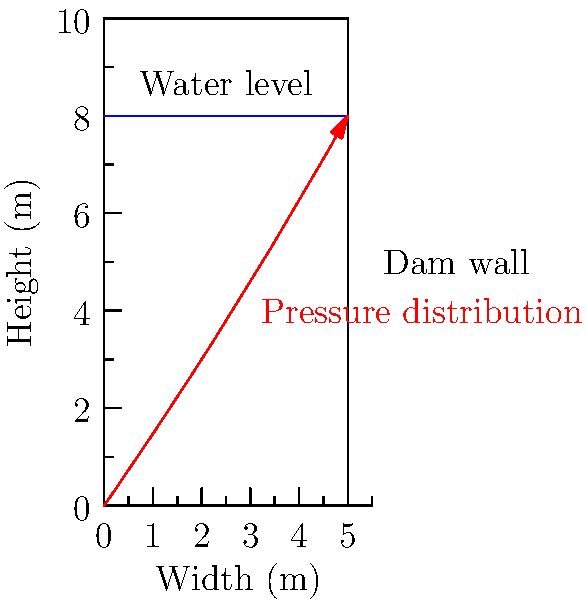In the context of ancient Sumerian hydraulic engineering, consider a dam wall with a height of 10 meters and a water level of 8 meters. How would you describe the water pressure distribution on the dam wall, and what shape would it most closely resemble in their conceptual understanding? To answer this question, let's break it down step-by-step, considering the ancient Sumerian perspective:

1. Water pressure basics:
   - Water pressure increases with depth due to the weight of the water above.
   - At the surface, the pressure is atmospheric (considered zero in this context).

2. Pressure distribution:
   - The pressure at any point is proportional to the depth below the water surface.
   - This creates a linear increase in pressure from top to bottom.

3. Shape of pressure distribution:
   - The pressure starts at zero at the water surface (8m height).
   - It increases linearly to a maximum at the bottom of the dam (0m height).
   - This forms a triangular shape.

4. Ancient Sumerian interpretation:
   - Sumerians were advanced in mathematics and geometry.
   - They would likely conceptualize this as a wedge or triangular shape.
   - In their literature, they might describe it as an "inverted mountain" or "water's weight growing like a planted reed."

5. Mathematical representation:
   - The pressure at depth $h$ is given by $P = \rho g h$
   - Where $\rho$ is water density, $g$ is gravitational acceleration
   - The maximum pressure at the bottom: $P_{max} = \rho g H$
   - $H$ is the total water depth (8m in this case)

6. Sumerian relevance:
   - This understanding would have been crucial for their irrigation systems and flood control measures, often mentioned in their literature.

Therefore, the water pressure distribution on the dam wall would form a triangular shape, starting from zero at the water surface and increasing linearly to a maximum at the bottom, which the Sumerians might have conceptualized as an inverted wedge or growing reed.
Answer: Triangular distribution, conceptualized as an inverted wedge or growing reed in Sumerian understanding. 